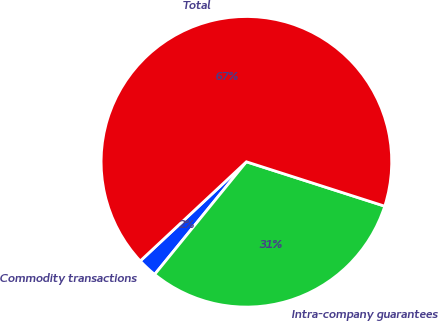Convert chart to OTSL. <chart><loc_0><loc_0><loc_500><loc_500><pie_chart><fcel>Commodity transactions<fcel>Intra-company guarantees<fcel>Total<nl><fcel>2.16%<fcel>30.94%<fcel>66.91%<nl></chart> 